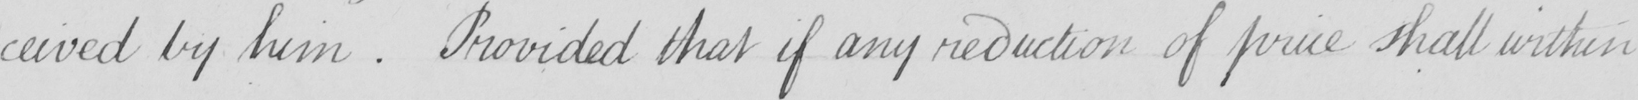Transcribe the text shown in this historical manuscript line. -ceived by him . Provided that if any reduction of price shall within 